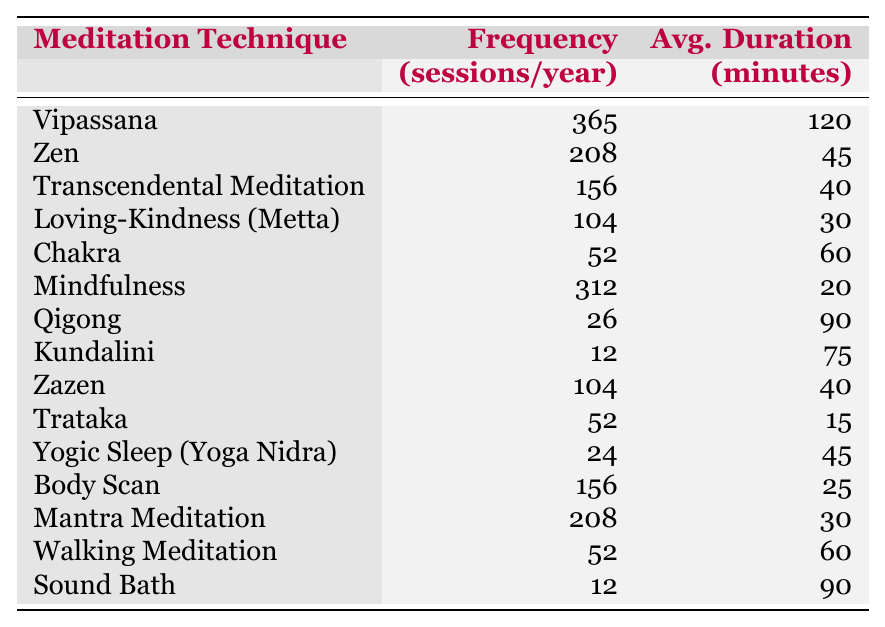What is the most frequently practiced meditation technique? The table shows that Vipassana has the highest frequency with 365 sessions per year.
Answer: Vipassana How many sessions of Mindfulness meditation are practiced per year? The table states that Mindfulness is practiced 312 sessions per year.
Answer: 312 What is the average duration of a Qigong session? According to the table, the average duration of a Qigong session is 90 minutes.
Answer: 90 minutes Which meditation techniques have a frequency of 52 sessions per year? The techniques listed with 52 sessions per year are Chakra, Trataka, and Walking Meditation.
Answer: Chakra, Trataka, Walking Meditation What is the total frequency of sessions for Transcendental Meditation and Body Scan combined? The frequency of Transcendental Meditation is 156 sessions and Body Scan is 156 sessions. Their sum is 156 + 156 = 312.
Answer: 312 Are there more meditation techniques with a frequency greater than 100 or less than 100? Counting the techniques, there are 6 with more than 100 sessions (Vipassana, Zen, Mindfulness, Transcendental Meditation, Loving-Kindness, and Body Scan) and 8 with less than 100 sessions. Since 8 is greater than 6, the answer is yes.
Answer: Yes What is the average duration of the meditation techniques practiced 104 times in a year? The meditation techniques practiced 104 times are Loving-Kindness and Zazen. Their average durations are 30 minutes and 40 minutes respectively. The average is (30 + 40) / 2 = 35 minutes.
Answer: 35 minutes Which meditation technique has both the highest frequency and duration? Looking at the frequency column, Vipassana has the highest frequency (365) and an average duration of 120 minutes. No other technique has both criteria met.
Answer: Vipassana What is the difference in frequency between Mantra Meditation and Kundalini? Mantra Meditation has 208 sessions and Kundalini has 12 sessions. The difference is 208 - 12 = 196.
Answer: 196 Is the average session duration of Loving-Kindness meditation more than 30 minutes? The average duration for Loving-Kindness meditation is given as 30 minutes. Since the average is not greater than 30 minutes, the answer is no.
Answer: No 